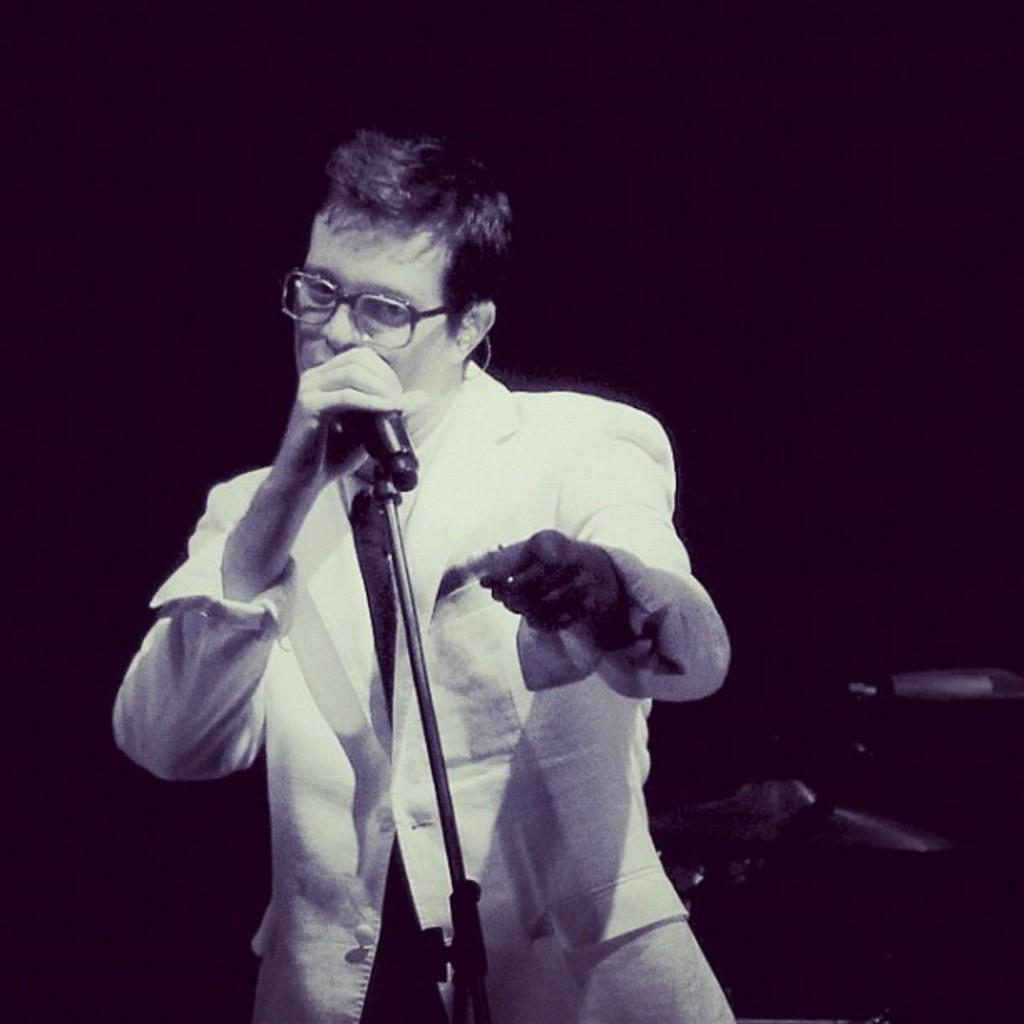What is the color scheme of the image? The image is black and white. Can you describe the person in the image? There is a person in the image. What is the person holding in the image? The person is holding a microphone. How many tomatoes can be seen in the image? There are no tomatoes present in the image. What type of copy is the person attempting to make in the image? There is no copying or attempt to copy anything visible in the image. 